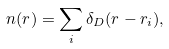Convert formula to latex. <formula><loc_0><loc_0><loc_500><loc_500>n ( { r } ) = \sum _ { i } \delta _ { D } ( { r } - { r } _ { i } ) ,</formula> 